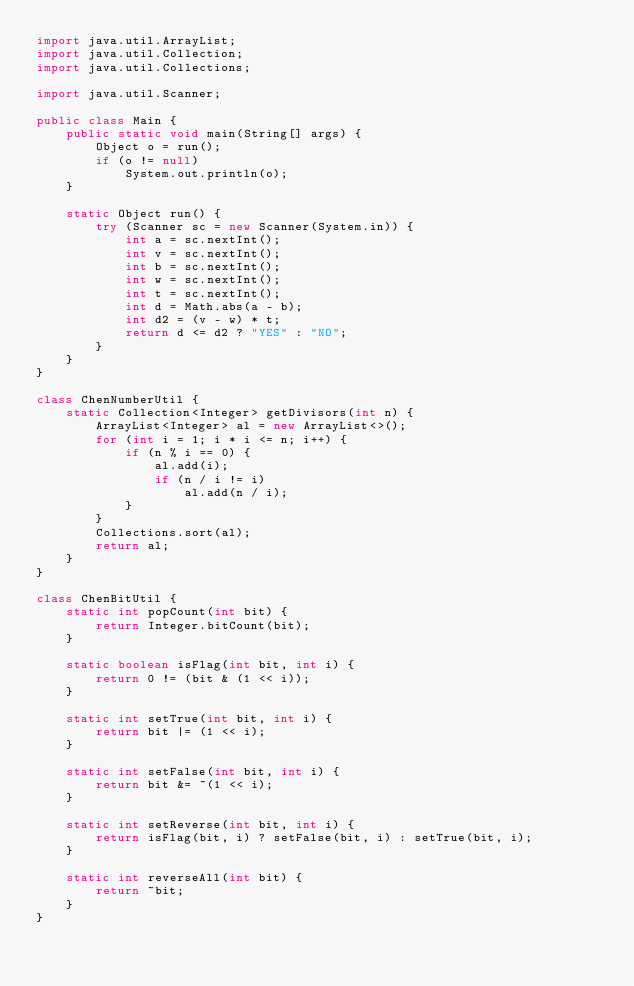Convert code to text. <code><loc_0><loc_0><loc_500><loc_500><_Java_>import java.util.ArrayList;
import java.util.Collection;
import java.util.Collections;

import java.util.Scanner;

public class Main {
    public static void main(String[] args) {
        Object o = run();
        if (o != null)
            System.out.println(o);
    }

    static Object run() {
        try (Scanner sc = new Scanner(System.in)) {
            int a = sc.nextInt();
            int v = sc.nextInt();
            int b = sc.nextInt();
            int w = sc.nextInt();
            int t = sc.nextInt();
            int d = Math.abs(a - b);
            int d2 = (v - w) * t;
            return d <= d2 ? "YES" : "NO";
        }
    }
}

class ChenNumberUtil {
    static Collection<Integer> getDivisors(int n) {
        ArrayList<Integer> al = new ArrayList<>();
        for (int i = 1; i * i <= n; i++) {
            if (n % i == 0) {
                al.add(i);
                if (n / i != i)
                    al.add(n / i);
            }
        }
        Collections.sort(al);
        return al;
    }
}

class ChenBitUtil {
    static int popCount(int bit) {
        return Integer.bitCount(bit);
    }

    static boolean isFlag(int bit, int i) {
        return 0 != (bit & (1 << i));
    }

    static int setTrue(int bit, int i) {
        return bit |= (1 << i);
    }

    static int setFalse(int bit, int i) {
        return bit &= ~(1 << i);
    }

    static int setReverse(int bit, int i) {
        return isFlag(bit, i) ? setFalse(bit, i) : setTrue(bit, i);
    }

    static int reverseAll(int bit) {
        return ~bit;
    }
}
</code> 